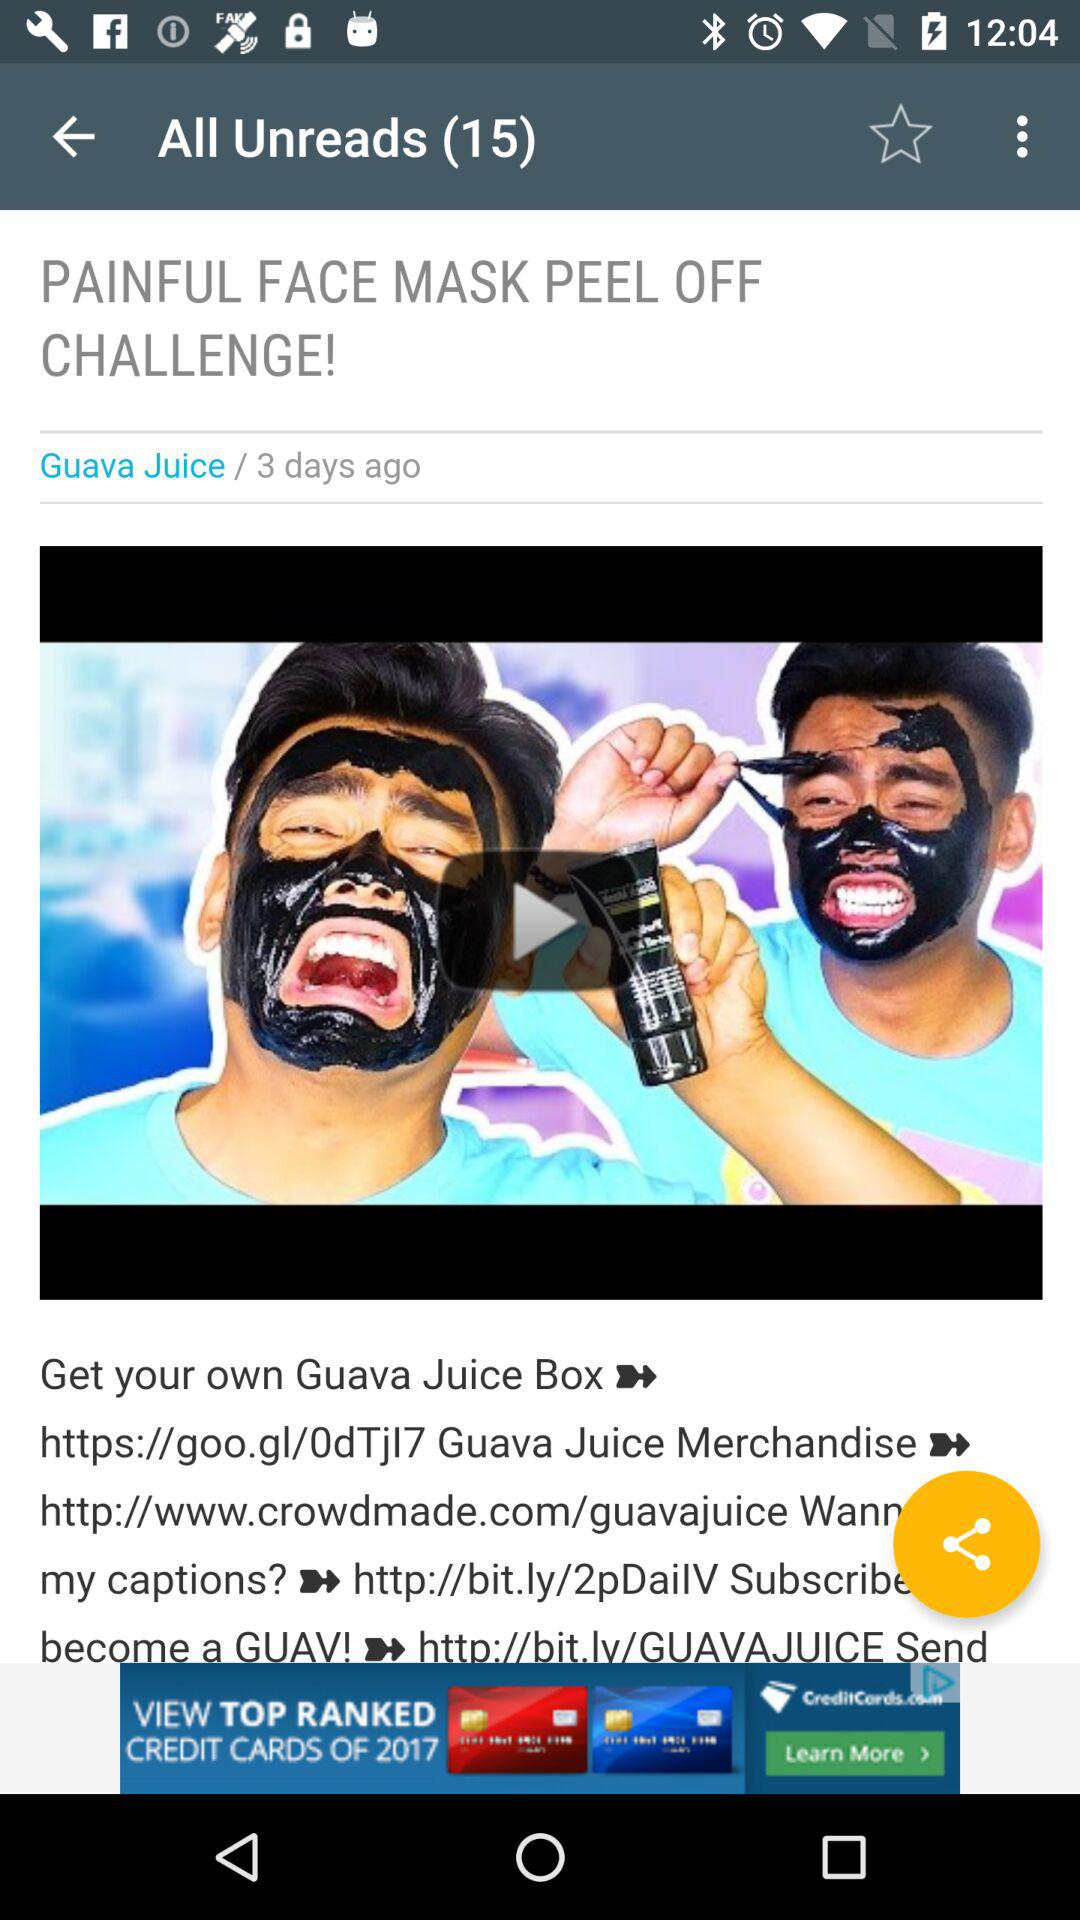Who posted the article? The article was posted by "Guava Juice". 